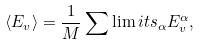Convert formula to latex. <formula><loc_0><loc_0><loc_500><loc_500>\langle E _ { v } \rangle = \frac { 1 } { M } \sum \lim i t s _ { \alpha } { E ^ { \alpha } _ { v } } ,</formula> 